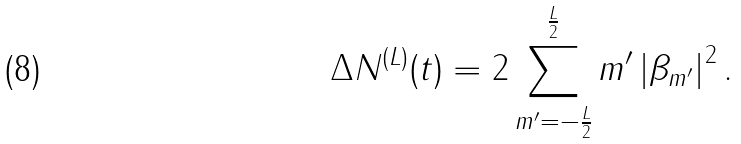Convert formula to latex. <formula><loc_0><loc_0><loc_500><loc_500>\Delta N ^ { ( L ) } ( t ) = 2 \sum _ { m ^ { \prime } = - \frac { L } { 2 } } ^ { \frac { L } { 2 } } m ^ { \prime } \left | \beta _ { m ^ { \prime } } \right | ^ { 2 } .</formula> 